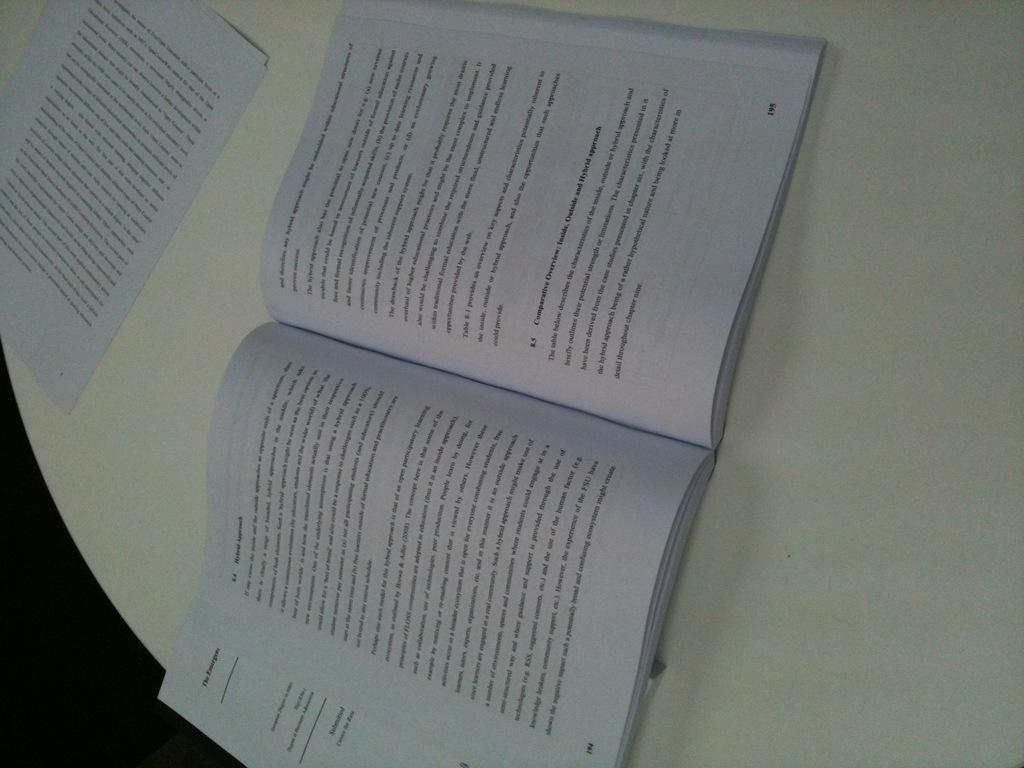What is the main object in the middle of the image? There is a book in the middle of the image. What else can be seen on the left side of the image? There are papers on the left side of the image. How many spiders are crawling on the book in the image? There are no spiders present in the image; it only shows a book and papers. What type of care is being provided to the book in the image? The image does not show any care being provided to the book; it simply displays the book and papers. 